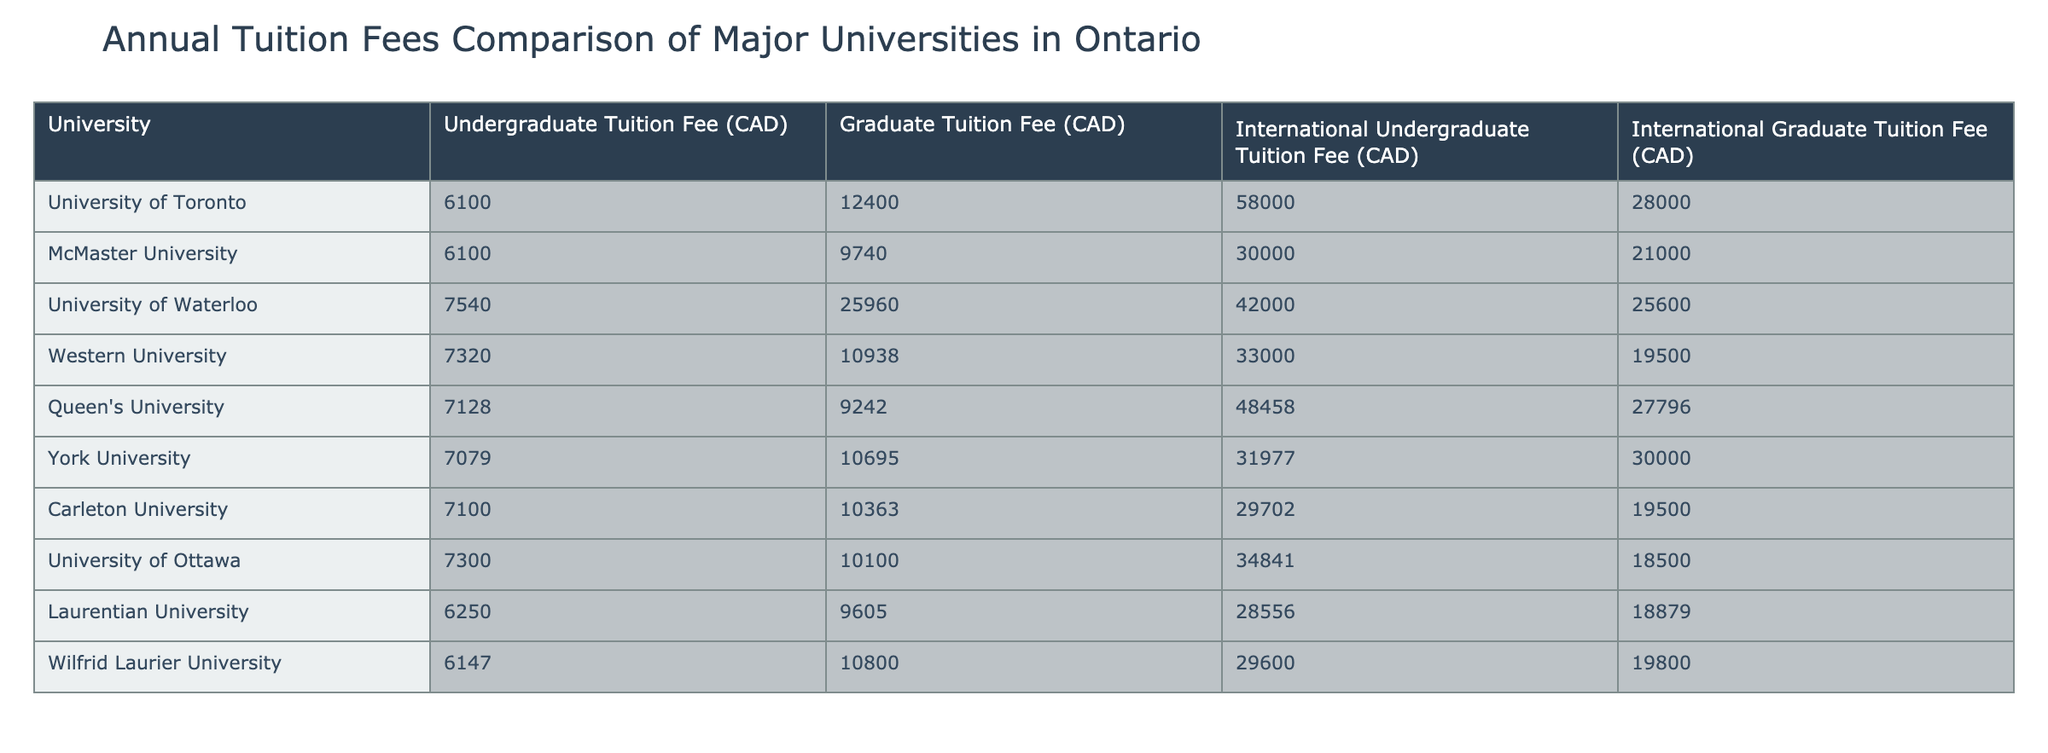What is the undergraduate tuition fee for McMaster University? The undergraduate tuition fee for McMaster University is listed directly in the table under the respective column. It is 6100 CAD.
Answer: 6100 CAD Which university has the highest international graduate tuition fee? By examining the 'International Graduate Tuition Fee' column, University of Toronto has the highest fee at 28000 CAD.
Answer: University of Toronto What is the difference between the international undergraduate tuition fees of the University of Toronto and York University? The international undergraduate tuition fee for the University of Toronto is 58000 CAD, while for York University, it is 31977 CAD. The difference is calculated as 58000 - 31977 = 26023 CAD.
Answer: 26023 CAD Are the graduate tuition fees at Queen's University higher than those at Laurentian University? The graduate tuition fee for Queen's University is 9242 CAD, while Laurentian University charges 9605 CAD. Comparing these values shows that Laurentian University has a higher fee.
Answer: Yes What is the average undergraduate tuition fee among the universities listed? To find the average, sum all undergraduate fees: 6100 + 6100 + 7540 + 7320 + 7128 + 7079 + 7100 + 7300 + 6250 + 6147 = 7134. The average is then 71340 / 10 = 7134 CAD.
Answer: 7134 CAD Which university has a graduate tuition fee closest to the average of 10214 CAD? To find the closest graduate tuition fee, we compare each university's graduate fee to the average. The closest fee is 10363 CAD from Carleton University.
Answer: Carleton University Does Western University have a higher international undergraduate tuition fee than the University of Ottawa? From the table, the international undergraduate fee for Western University is 33000 CAD, and for the University of Ottawa, it is 34841 CAD. Since 33000 is less than 34841, Western University does not have a higher fee.
Answer: No What is the total of the international graduate tuition fees for the three universities with the lowest fees? The three universities with the lowest international graduate fees are University of Ottawa (18500 CAD), Carleton University (19500 CAD), and Western University (19500 CAD). The total is 18500 + 19500 + 19500 = 57500 CAD.
Answer: 57500 CAD What is the range of undergraduate tuition fees across these universities? To find the range, we identify the lowest undergraduate fee (6250 CAD at Laurentian University) and the highest fee (7540 CAD at University of Waterloo). The range is calculated as 7540 - 6250 = 1290 CAD.
Answer: 1290 CAD 